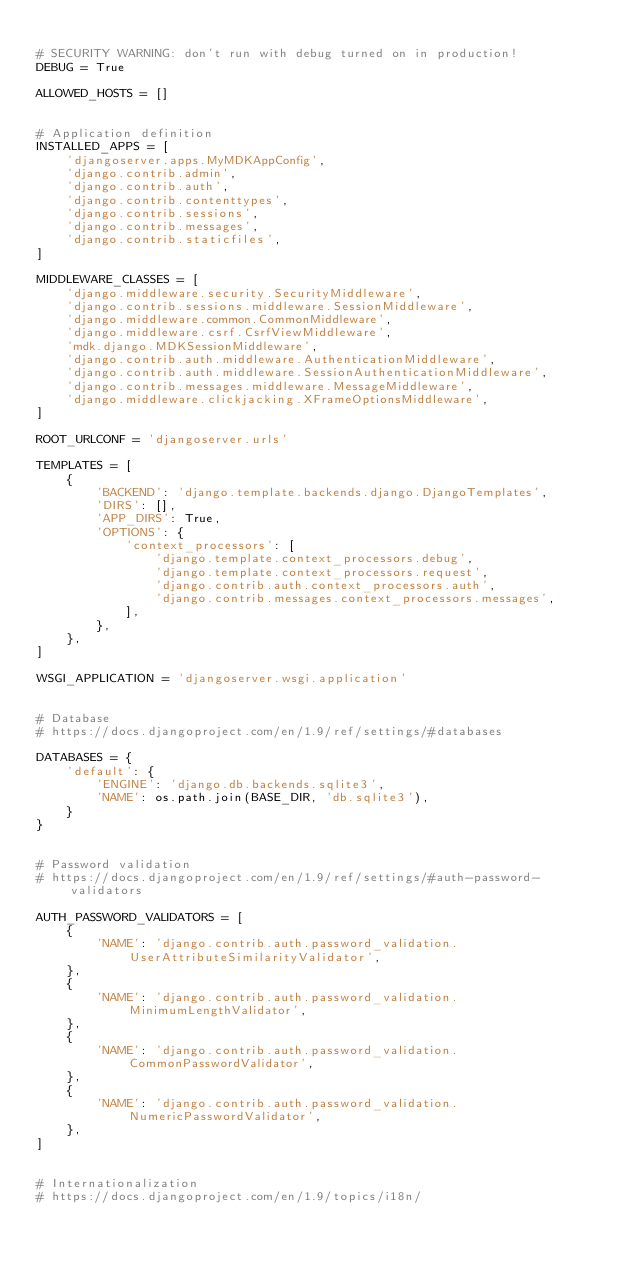<code> <loc_0><loc_0><loc_500><loc_500><_Python_>
# SECURITY WARNING: don't run with debug turned on in production!
DEBUG = True

ALLOWED_HOSTS = []


# Application definition
INSTALLED_APPS = [
    'djangoserver.apps.MyMDKAppConfig',
    'django.contrib.admin',
    'django.contrib.auth',
    'django.contrib.contenttypes',
    'django.contrib.sessions',
    'django.contrib.messages',
    'django.contrib.staticfiles',
]

MIDDLEWARE_CLASSES = [
    'django.middleware.security.SecurityMiddleware',
    'django.contrib.sessions.middleware.SessionMiddleware',
    'django.middleware.common.CommonMiddleware',
    'django.middleware.csrf.CsrfViewMiddleware',
    'mdk.django.MDKSessionMiddleware',
    'django.contrib.auth.middleware.AuthenticationMiddleware',
    'django.contrib.auth.middleware.SessionAuthenticationMiddleware',
    'django.contrib.messages.middleware.MessageMiddleware',
    'django.middleware.clickjacking.XFrameOptionsMiddleware',
]

ROOT_URLCONF = 'djangoserver.urls'

TEMPLATES = [
    {
        'BACKEND': 'django.template.backends.django.DjangoTemplates',
        'DIRS': [],
        'APP_DIRS': True,
        'OPTIONS': {
            'context_processors': [
                'django.template.context_processors.debug',
                'django.template.context_processors.request',
                'django.contrib.auth.context_processors.auth',
                'django.contrib.messages.context_processors.messages',
            ],
        },
    },
]

WSGI_APPLICATION = 'djangoserver.wsgi.application'


# Database
# https://docs.djangoproject.com/en/1.9/ref/settings/#databases

DATABASES = {
    'default': {
        'ENGINE': 'django.db.backends.sqlite3',
        'NAME': os.path.join(BASE_DIR, 'db.sqlite3'),
    }
}


# Password validation
# https://docs.djangoproject.com/en/1.9/ref/settings/#auth-password-validators

AUTH_PASSWORD_VALIDATORS = [
    {
        'NAME': 'django.contrib.auth.password_validation.UserAttributeSimilarityValidator',
    },
    {
        'NAME': 'django.contrib.auth.password_validation.MinimumLengthValidator',
    },
    {
        'NAME': 'django.contrib.auth.password_validation.CommonPasswordValidator',
    },
    {
        'NAME': 'django.contrib.auth.password_validation.NumericPasswordValidator',
    },
]


# Internationalization
# https://docs.djangoproject.com/en/1.9/topics/i18n/
</code> 